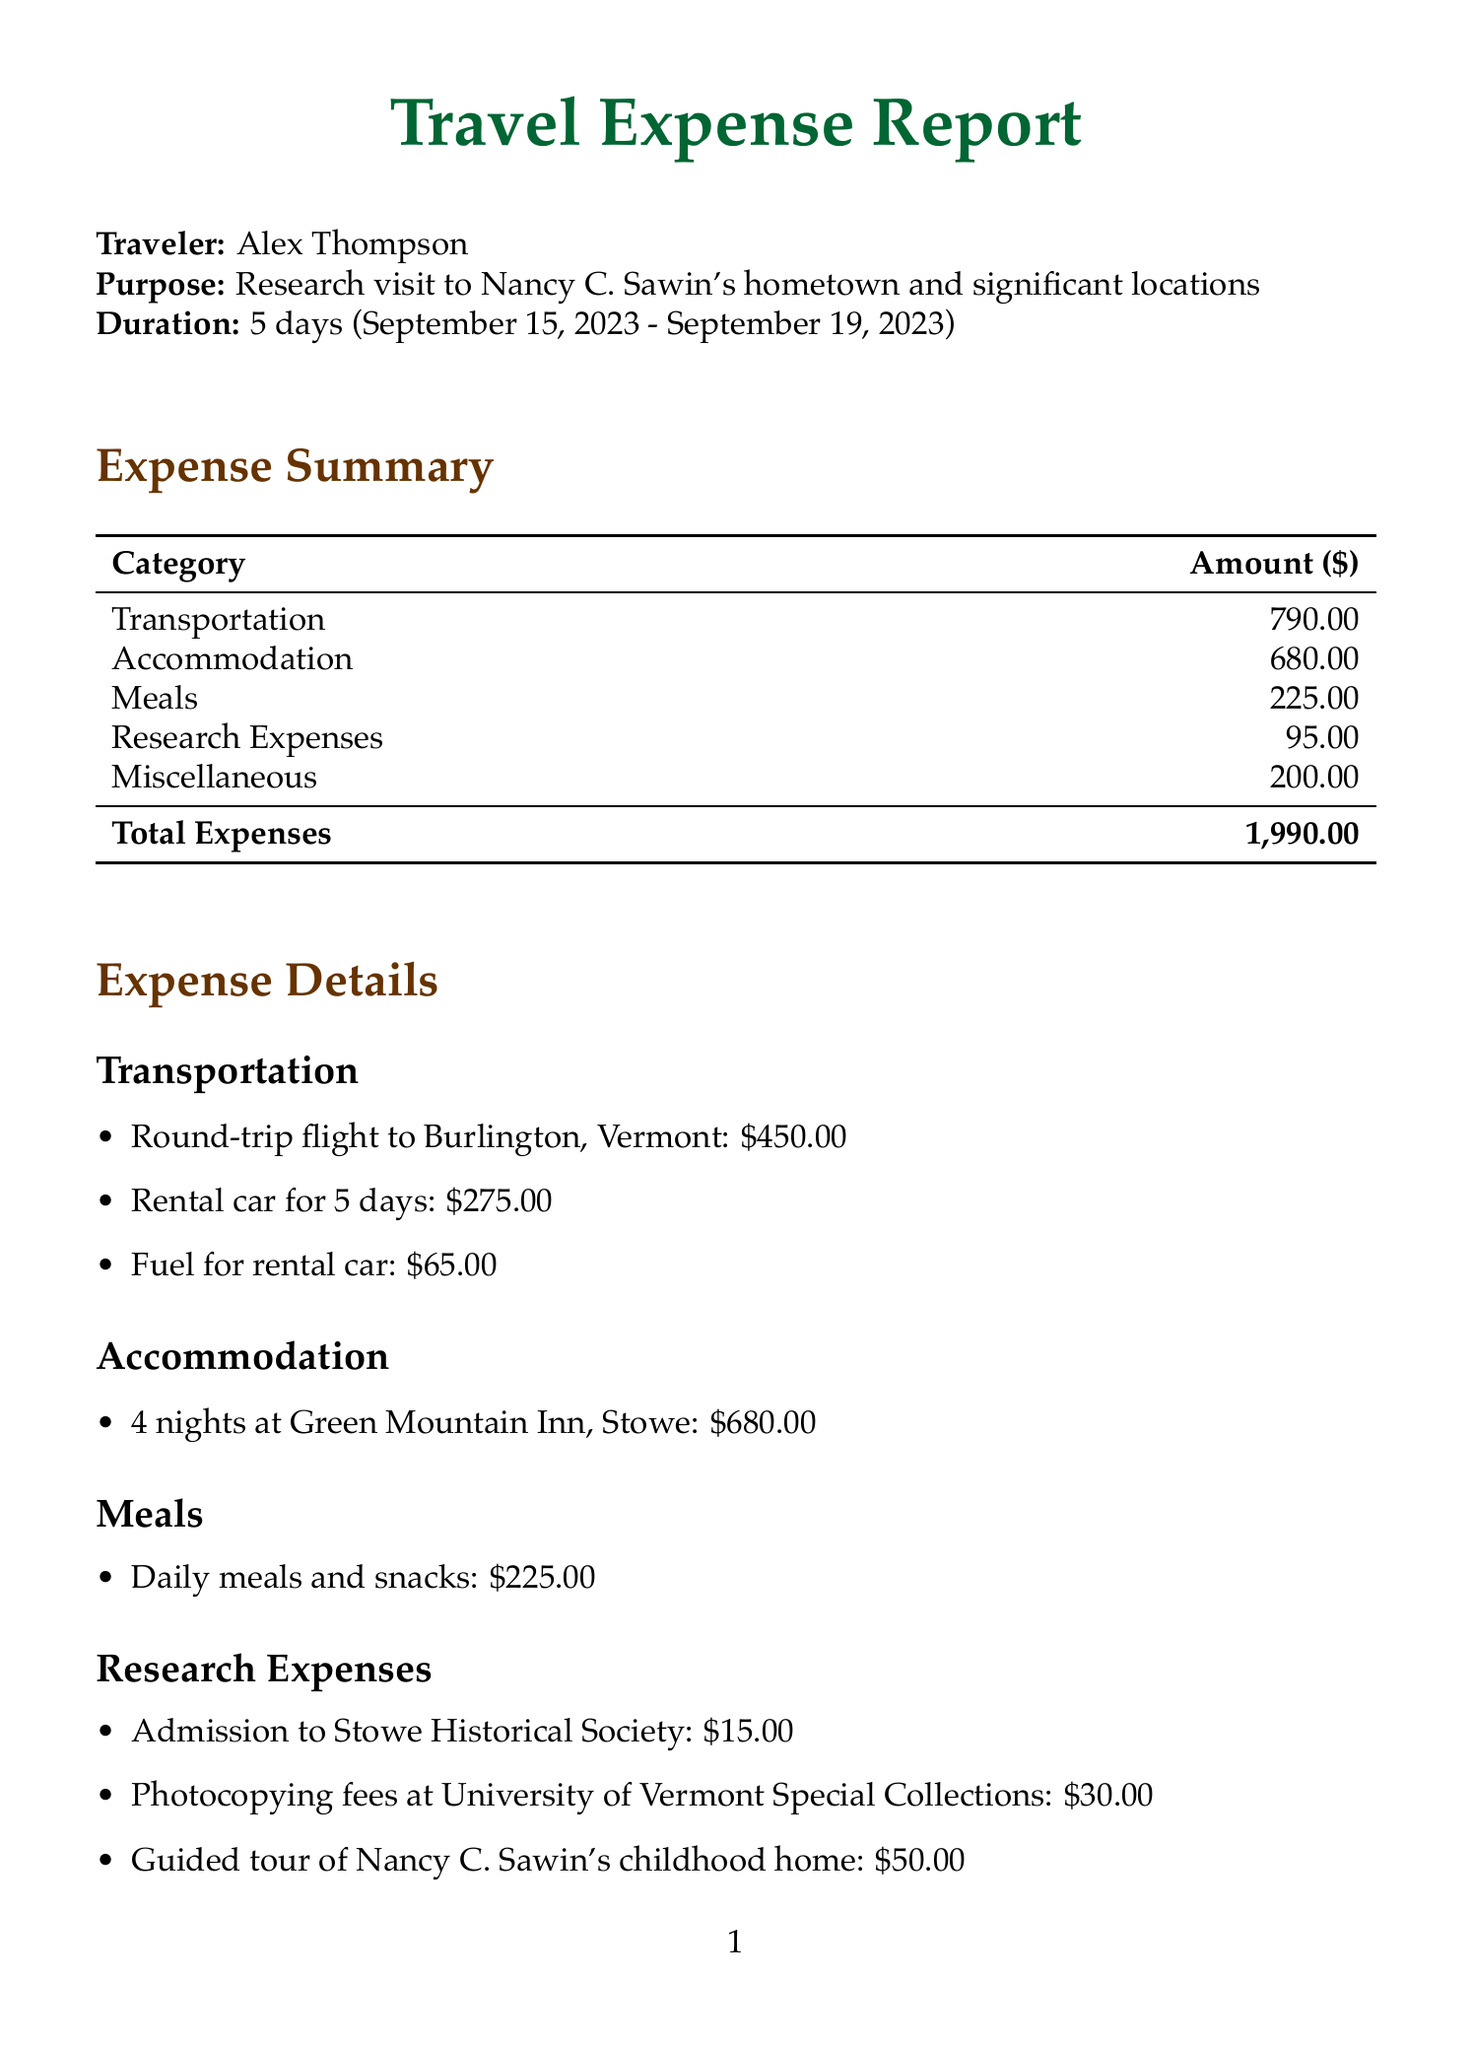what is the name of the traveler? The traveler's name is specified at the beginning of the document.
Answer: Alex Thompson what is the purpose of the trip? The purpose of the trip is stated in the document.
Answer: Research visit to Nancy C. Sawin's hometown and significant locations how many days did the trip last? The trip duration can be found in the document section detailing the trip.
Answer: 5 days when did the trip start? The departure date is mentioned in the document, explaining when the trip began.
Answer: September 15, 2023 what is the total amount of expenses incurred? The total expenses are summarized at the end of the expense summary section.
Answer: 1,990.00 how much was spent on meals? The amount spent on meals is provided in the expense details under the meals category.
Answer: 225.00 how much was paid for the guided tour of Nancy C. Sawin's childhood home? The cost for the guided tour is listed in the research expenses section.
Answer: 50.00 which hotel did the traveler stay at? The accommodation name is listed under the accommodation category in the expenses.
Answer: Green Mountain Inn, Stowe what were some significant locations explored during the trip? The significant locations related to Nancy C. Sawin's life are detailed in the research notes section.
Answer: Mount Mansfield and Smugglers' Notch 